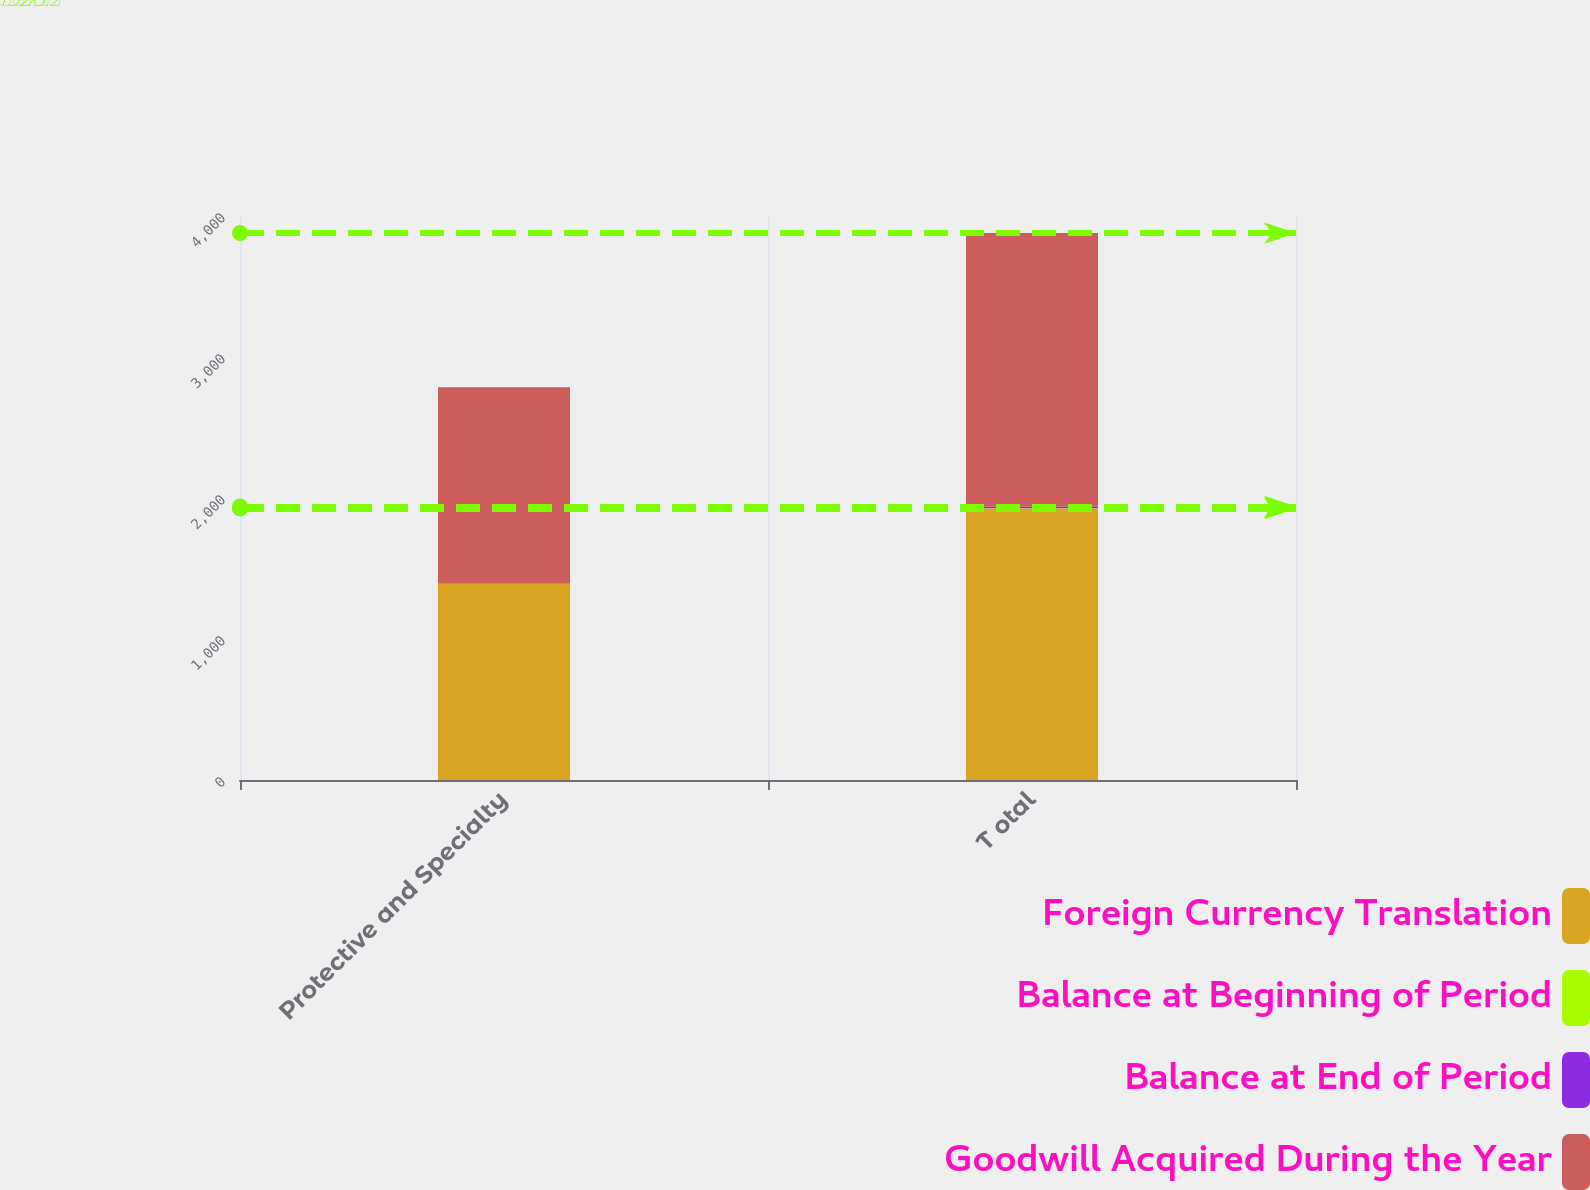Convert chart to OTSL. <chart><loc_0><loc_0><loc_500><loc_500><stacked_bar_chart><ecel><fcel>Protective and Specialty<fcel>T otal<nl><fcel>Foreign Currency Translation<fcel>1390.9<fcel>1926.2<nl><fcel>Balance at Beginning of Period<fcel>0.5<fcel>0.5<nl><fcel>Balance at End of Period<fcel>0.9<fcel>12.8<nl><fcel>Goodwill Acquired During the Year<fcel>1392.3<fcel>1939.5<nl></chart> 